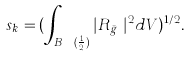Convert formula to latex. <formula><loc_0><loc_0><loc_500><loc_500>s _ { k } = ( \int _ { B _ { y _ { k } } ( \frac { 1 } { 2 } ) } | R _ { \bar { g } _ { k } } | ^ { 2 } d V ) ^ { 1 / 2 } .</formula> 